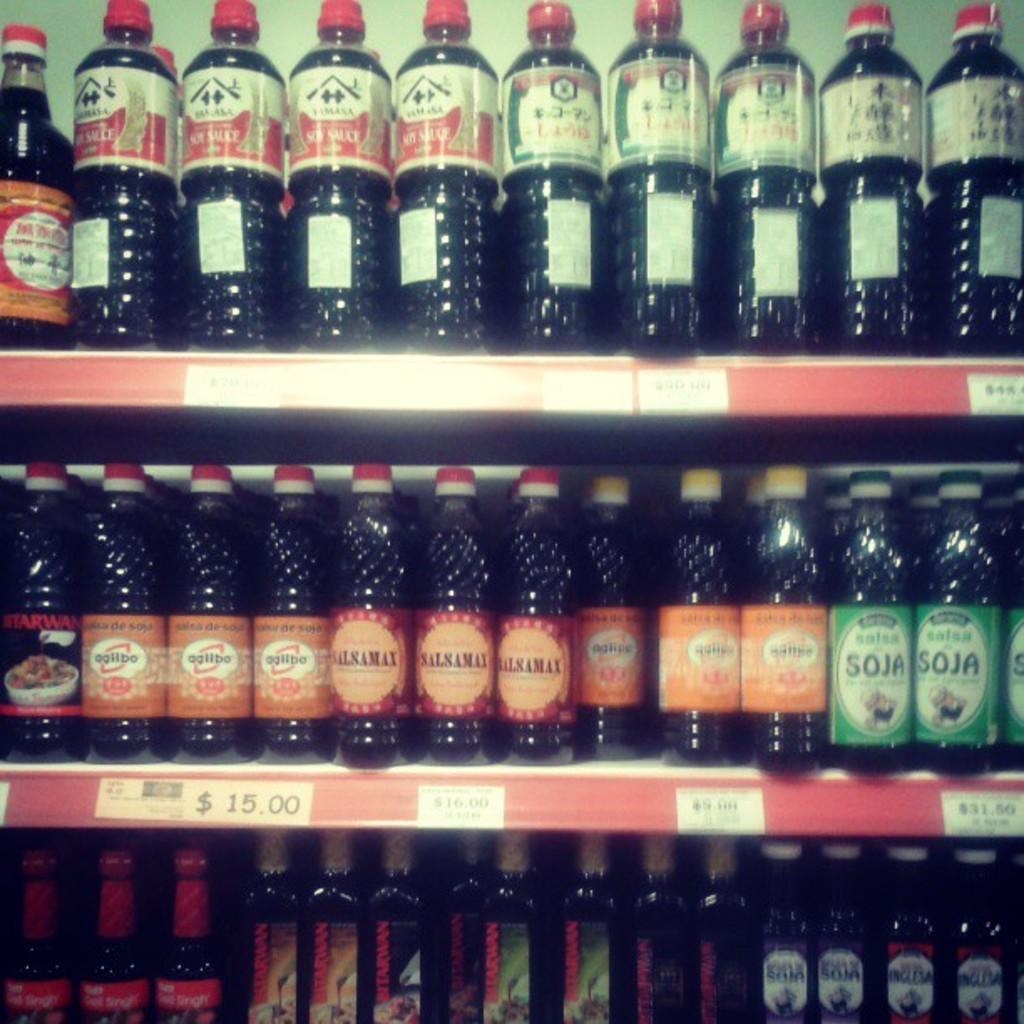<image>
Share a concise interpretation of the image provided. $15.00 bottle of Agllbo is next to a $16 bottle of Salsamai 